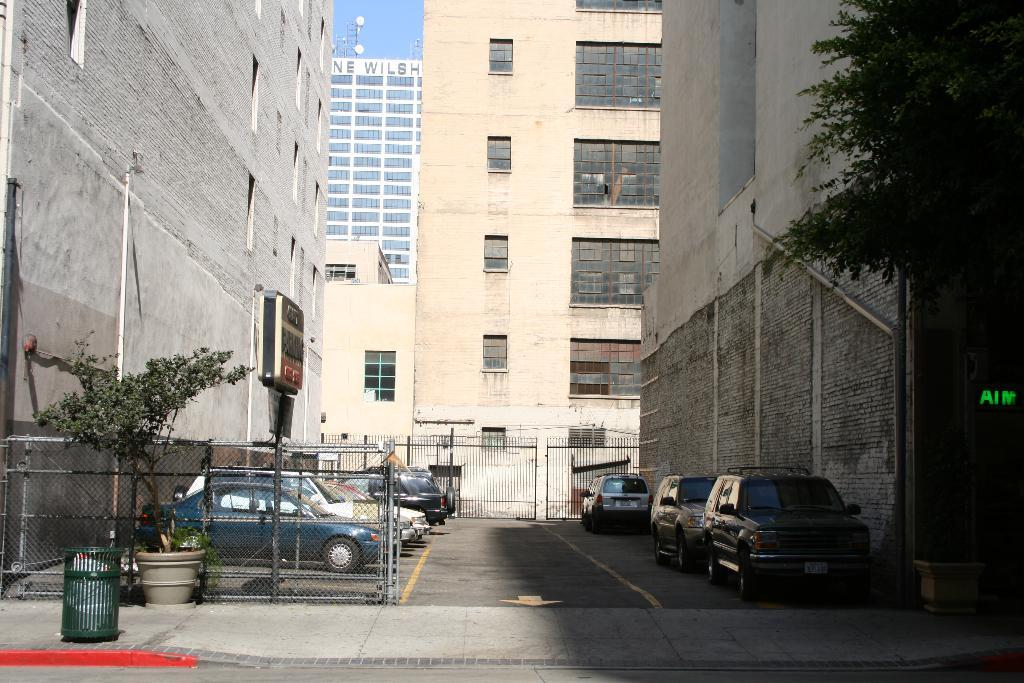What types of objects are in the image? There are vehicles, a plant, a fence, a road, boards, branches, buildings, and the sky is visible in the image. Can you describe the landscape in the image? The image features a road, buildings, and a plant, with a fence and branches also present. What is the primary mode of transportation in the image? Vehicles are the primary mode of transportation in the image. Where is the playground located in the image? There is no playground present in the image. What type of muscle can be seen flexing in the image? There are no muscles visible in the image. 